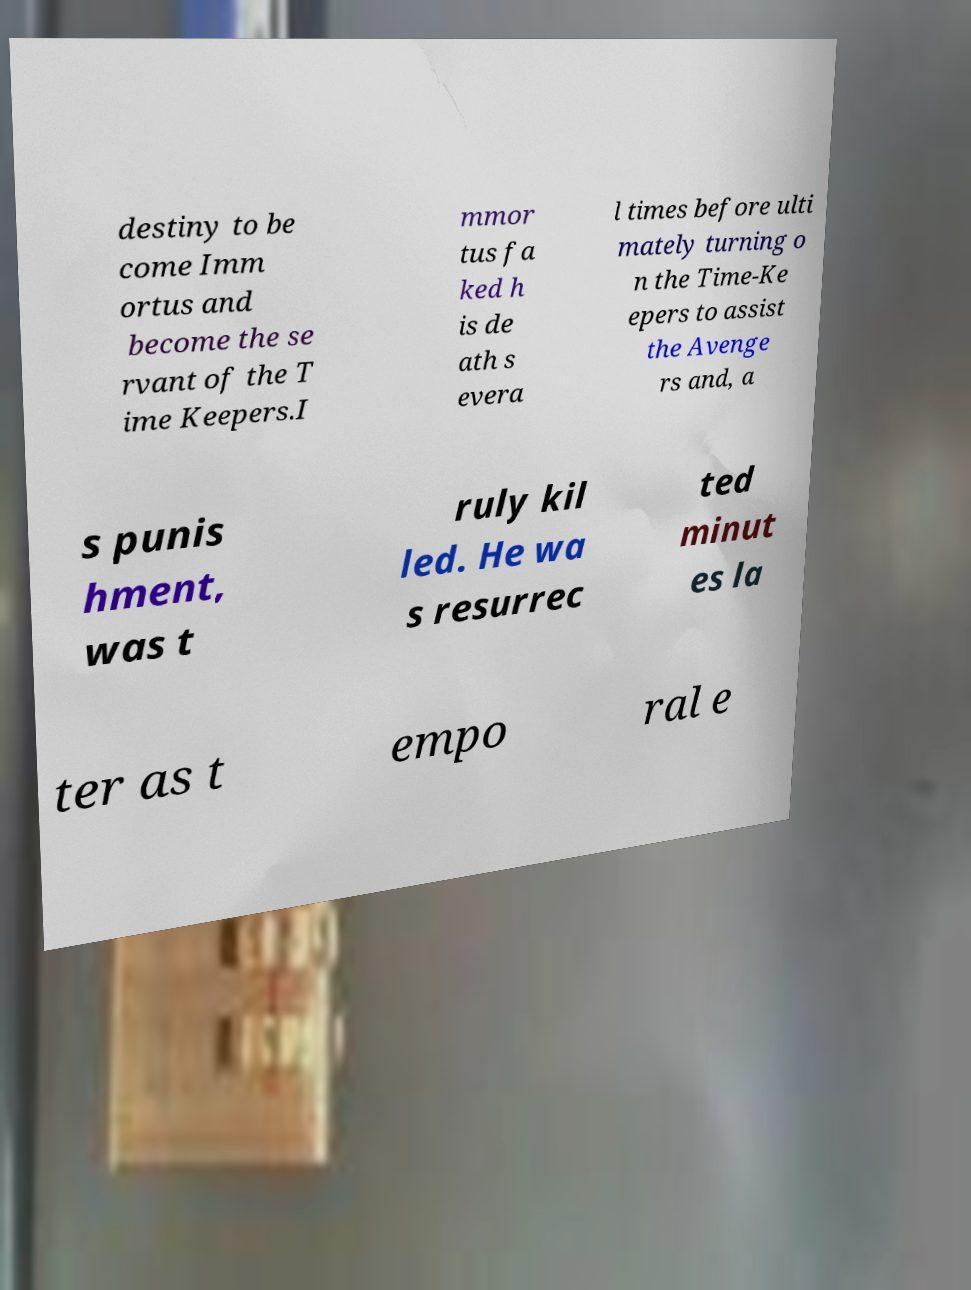Please identify and transcribe the text found in this image. destiny to be come Imm ortus and become the se rvant of the T ime Keepers.I mmor tus fa ked h is de ath s evera l times before ulti mately turning o n the Time-Ke epers to assist the Avenge rs and, a s punis hment, was t ruly kil led. He wa s resurrec ted minut es la ter as t empo ral e 